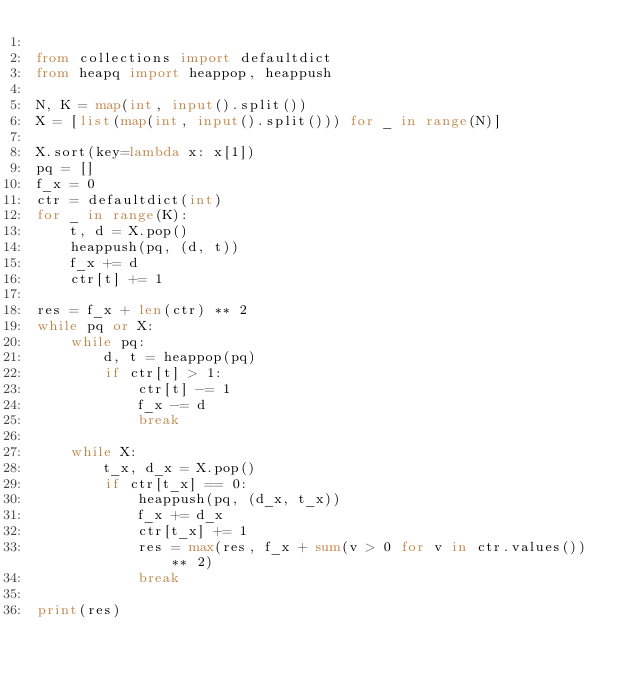Convert code to text. <code><loc_0><loc_0><loc_500><loc_500><_Python_>
from collections import defaultdict
from heapq import heappop, heappush

N, K = map(int, input().split())
X = [list(map(int, input().split())) for _ in range(N)]

X.sort(key=lambda x: x[1])
pq = []
f_x = 0
ctr = defaultdict(int)
for _ in range(K):
    t, d = X.pop()
    heappush(pq, (d, t))
    f_x += d
    ctr[t] += 1

res = f_x + len(ctr) ** 2
while pq or X:
    while pq:
        d, t = heappop(pq)
        if ctr[t] > 1:
            ctr[t] -= 1
            f_x -= d
            break

    while X:
        t_x, d_x = X.pop()
        if ctr[t_x] == 0:
            heappush(pq, (d_x, t_x))
            f_x += d_x
            ctr[t_x] += 1
            res = max(res, f_x + sum(v > 0 for v in ctr.values()) ** 2)
            break

print(res)
</code> 